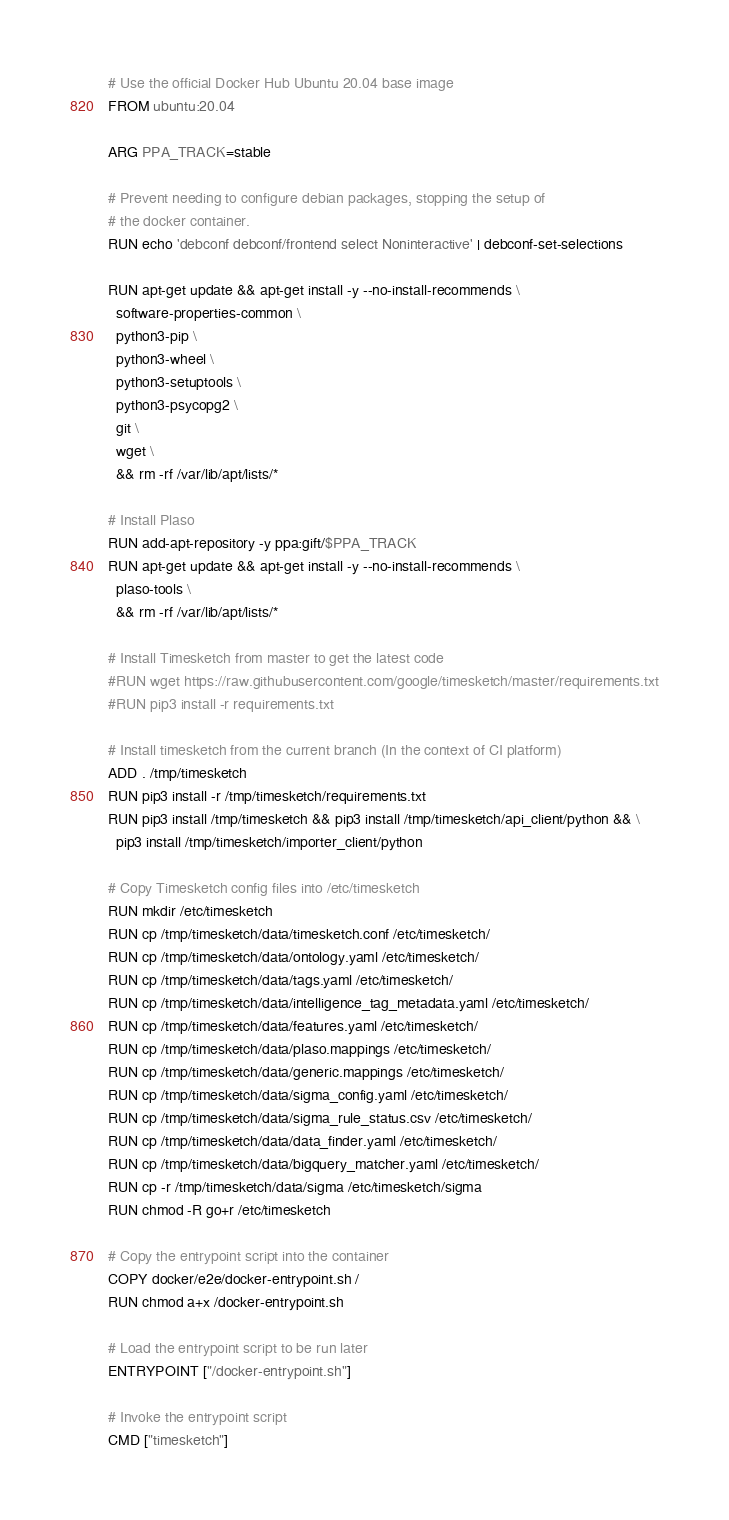Convert code to text. <code><loc_0><loc_0><loc_500><loc_500><_Dockerfile_># Use the official Docker Hub Ubuntu 20.04 base image
FROM ubuntu:20.04

ARG PPA_TRACK=stable

# Prevent needing to configure debian packages, stopping the setup of
# the docker container.
RUN echo 'debconf debconf/frontend select Noninteractive' | debconf-set-selections

RUN apt-get update && apt-get install -y --no-install-recommends \
  software-properties-common \
  python3-pip \
  python3-wheel \
  python3-setuptools \
  python3-psycopg2 \
  git \
  wget \
  && rm -rf /var/lib/apt/lists/*

# Install Plaso
RUN add-apt-repository -y ppa:gift/$PPA_TRACK
RUN apt-get update && apt-get install -y --no-install-recommends \
  plaso-tools \
  && rm -rf /var/lib/apt/lists/*

# Install Timesketch from master to get the latest code
#RUN wget https://raw.githubusercontent.com/google/timesketch/master/requirements.txt
#RUN pip3 install -r requirements.txt

# Install timesketch from the current branch (In the context of CI platform)
ADD . /tmp/timesketch
RUN pip3 install -r /tmp/timesketch/requirements.txt
RUN pip3 install /tmp/timesketch && pip3 install /tmp/timesketch/api_client/python && \
  pip3 install /tmp/timesketch/importer_client/python

# Copy Timesketch config files into /etc/timesketch
RUN mkdir /etc/timesketch
RUN cp /tmp/timesketch/data/timesketch.conf /etc/timesketch/
RUN cp /tmp/timesketch/data/ontology.yaml /etc/timesketch/
RUN cp /tmp/timesketch/data/tags.yaml /etc/timesketch/
RUN cp /tmp/timesketch/data/intelligence_tag_metadata.yaml /etc/timesketch/
RUN cp /tmp/timesketch/data/features.yaml /etc/timesketch/
RUN cp /tmp/timesketch/data/plaso.mappings /etc/timesketch/
RUN cp /tmp/timesketch/data/generic.mappings /etc/timesketch/
RUN cp /tmp/timesketch/data/sigma_config.yaml /etc/timesketch/
RUN cp /tmp/timesketch/data/sigma_rule_status.csv /etc/timesketch/
RUN cp /tmp/timesketch/data/data_finder.yaml /etc/timesketch/
RUN cp /tmp/timesketch/data/bigquery_matcher.yaml /etc/timesketch/
RUN cp -r /tmp/timesketch/data/sigma /etc/timesketch/sigma
RUN chmod -R go+r /etc/timesketch

# Copy the entrypoint script into the container
COPY docker/e2e/docker-entrypoint.sh /
RUN chmod a+x /docker-entrypoint.sh

# Load the entrypoint script to be run later
ENTRYPOINT ["/docker-entrypoint.sh"]

# Invoke the entrypoint script
CMD ["timesketch"]
</code> 